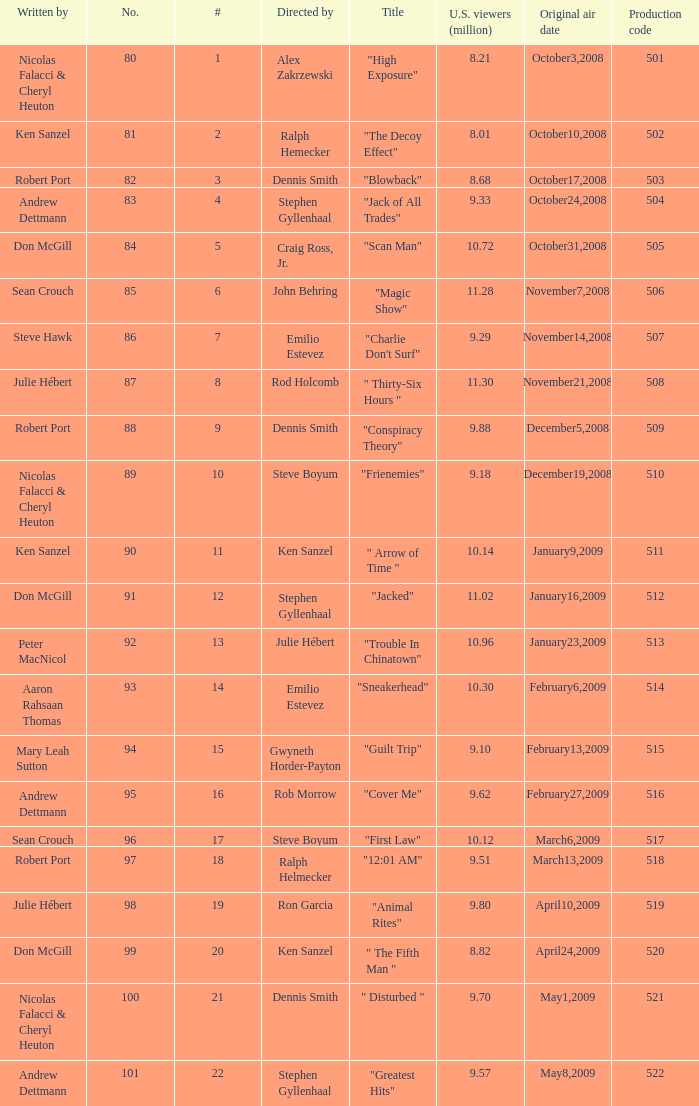What episode had 10.14 million viewers (U.S.)? 11.0. 